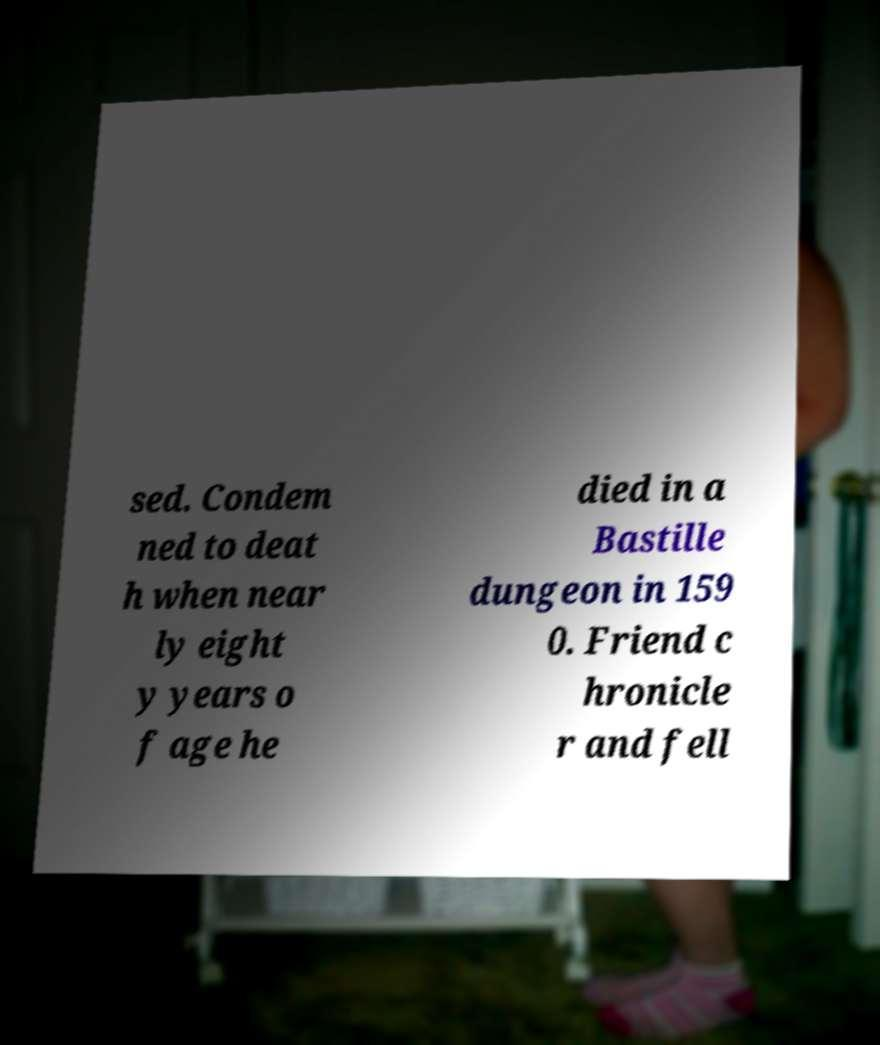Can you accurately transcribe the text from the provided image for me? sed. Condem ned to deat h when near ly eight y years o f age he died in a Bastille dungeon in 159 0. Friend c hronicle r and fell 